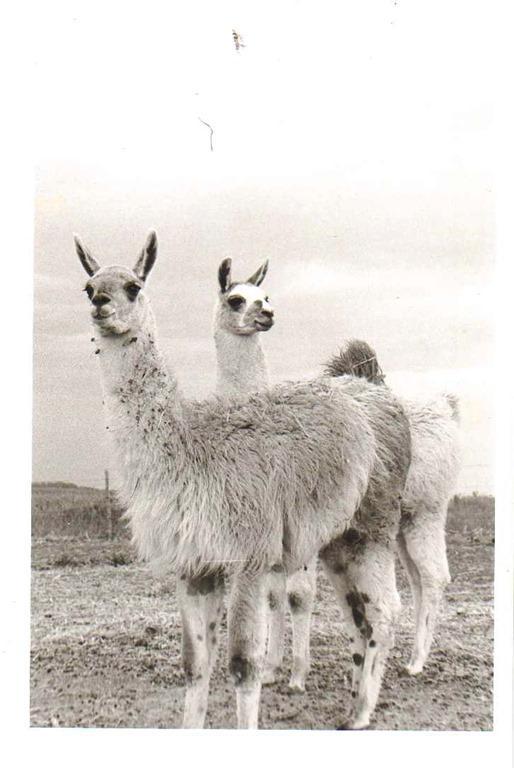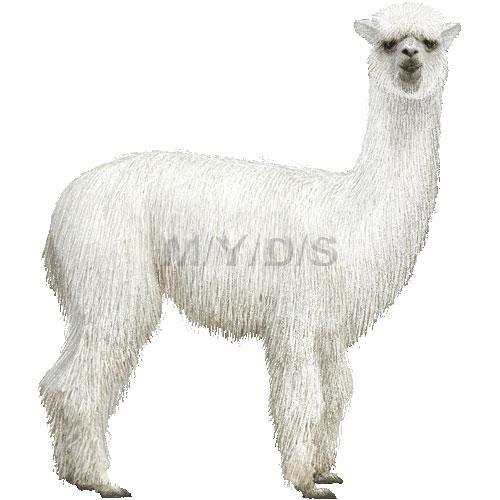The first image is the image on the left, the second image is the image on the right. Evaluate the accuracy of this statement regarding the images: "There are exactly three llamas.". Is it true? Answer yes or no. Yes. The first image is the image on the left, the second image is the image on the right. For the images shown, is this caption "Each image shows a single llama figure, which is standing in profile facing leftward." true? Answer yes or no. No. 